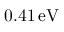<formula> <loc_0><loc_0><loc_500><loc_500>0 . 4 1 \, e V</formula> 